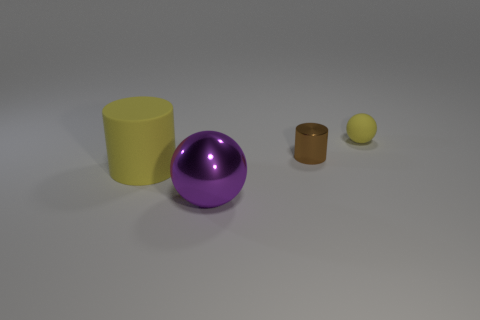The object that is the same material as the tiny yellow sphere is what size?
Offer a very short reply. Large. What color is the cylinder that is made of the same material as the large ball?
Give a very brief answer. Brown. Is there a yellow ball of the same size as the brown shiny thing?
Your answer should be very brief. Yes. There is another small object that is the same shape as the purple metal object; what is its material?
Give a very brief answer. Rubber. The metallic object that is the same size as the yellow sphere is what shape?
Your answer should be very brief. Cylinder. Are there any other tiny shiny objects that have the same shape as the small brown metallic thing?
Give a very brief answer. No. The metallic thing right of the sphere left of the tiny yellow matte sphere is what shape?
Keep it short and to the point. Cylinder. What shape is the small brown thing?
Give a very brief answer. Cylinder. The cylinder in front of the cylinder that is right of the yellow object in front of the small sphere is made of what material?
Offer a very short reply. Rubber. How many other objects are there of the same material as the big yellow thing?
Give a very brief answer. 1. 